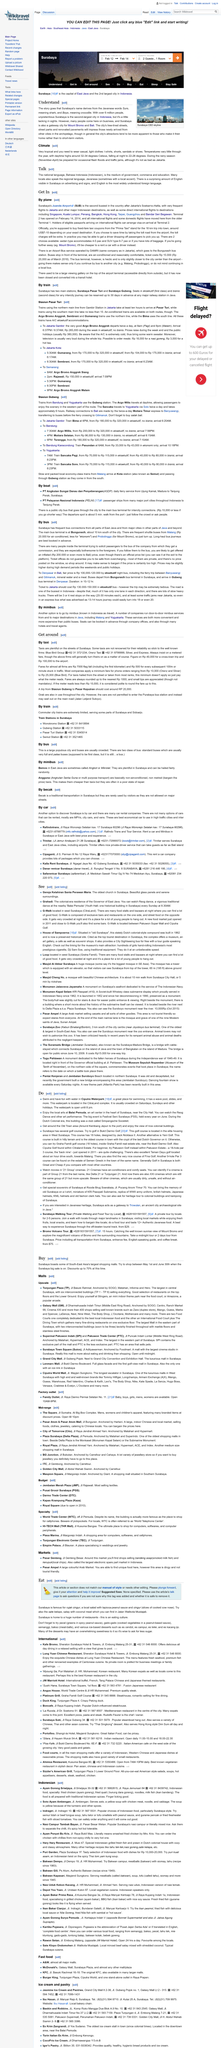Specify some key components in this picture. The traditional Reog dance can be viewed at the 'Balai Pernuda', a historical building in Surabaya, every Sunday at 8:30AM. The drive from Prima Taxi stand to Juanda Airport is 18 kilometers in length. The abundance of English in Surabaya is surprisingly evident. Yes, it is indeed very tropical. The fixed-fare from Prima Taxi to Juanda Airport is approximately 7-10 US dollars. 